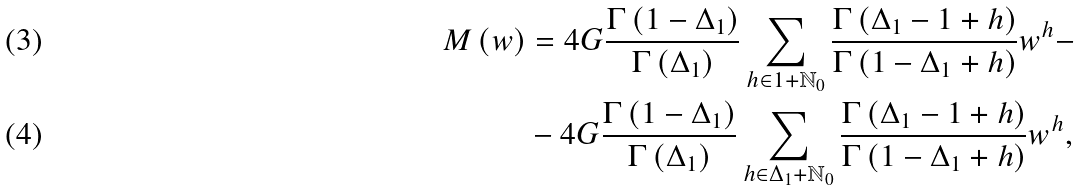<formula> <loc_0><loc_0><loc_500><loc_500>M \left ( w \right ) & = 4 G \frac { \Gamma \left ( 1 - \Delta _ { 1 } \right ) } { \Gamma \left ( \Delta _ { 1 } \right ) } \sum _ { h \in 1 + \mathbb { N } _ { 0 } } \frac { \Gamma \left ( \Delta _ { 1 } - 1 + h \right ) } { \Gamma \left ( 1 - \Delta _ { 1 } + h \right ) } w ^ { h } - \\ & - 4 G \frac { \Gamma \left ( 1 - \Delta _ { 1 } \right ) } { \Gamma \left ( \Delta _ { 1 } \right ) } \sum _ { h \in \Delta _ { 1 } + \mathbb { N } _ { 0 } } \frac { \Gamma \left ( \Delta _ { 1 } - 1 + h \right ) } { \Gamma \left ( 1 - \Delta _ { 1 } + h \right ) } w ^ { h } ,</formula> 